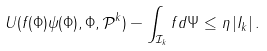Convert formula to latex. <formula><loc_0><loc_0><loc_500><loc_500>U ( f ( \Phi ) \psi ( \Phi ) , \Phi , \mathcal { P } ^ { k } ) - \int _ { \mathcal { I } _ { k } } f d \Psi \leq \eta \, | I _ { k } | \, .</formula> 